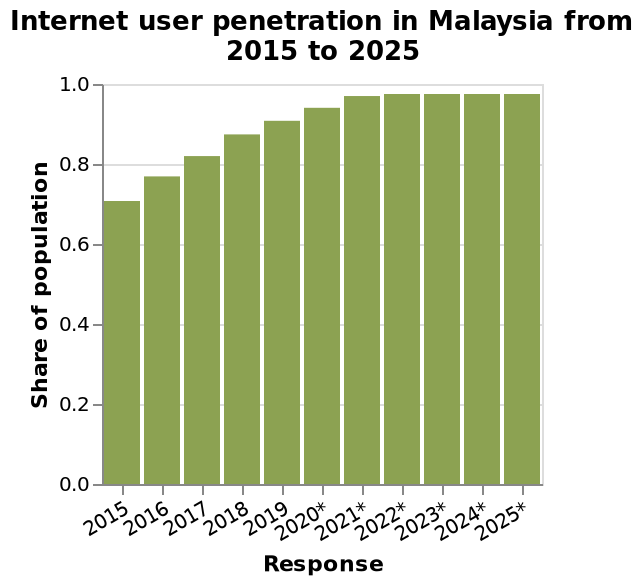<image>
What is the projected growth trend for the next five years starting from 2021? The growth is expected to stabilize and not show significant increases or decreases. What is expected to happen to the growth from 2021 to 2025?  The growth is expected to even out. How is the x-axis labeled in the bar graph? The x-axis of the bar graph is labeled as "Response" and represents the categorical scale from 2015 to 2025. What is the representation on the x-axis of the bar graph?  The x-axis of the bar graph represents the categorical scale starting from 2015 to 2025. 